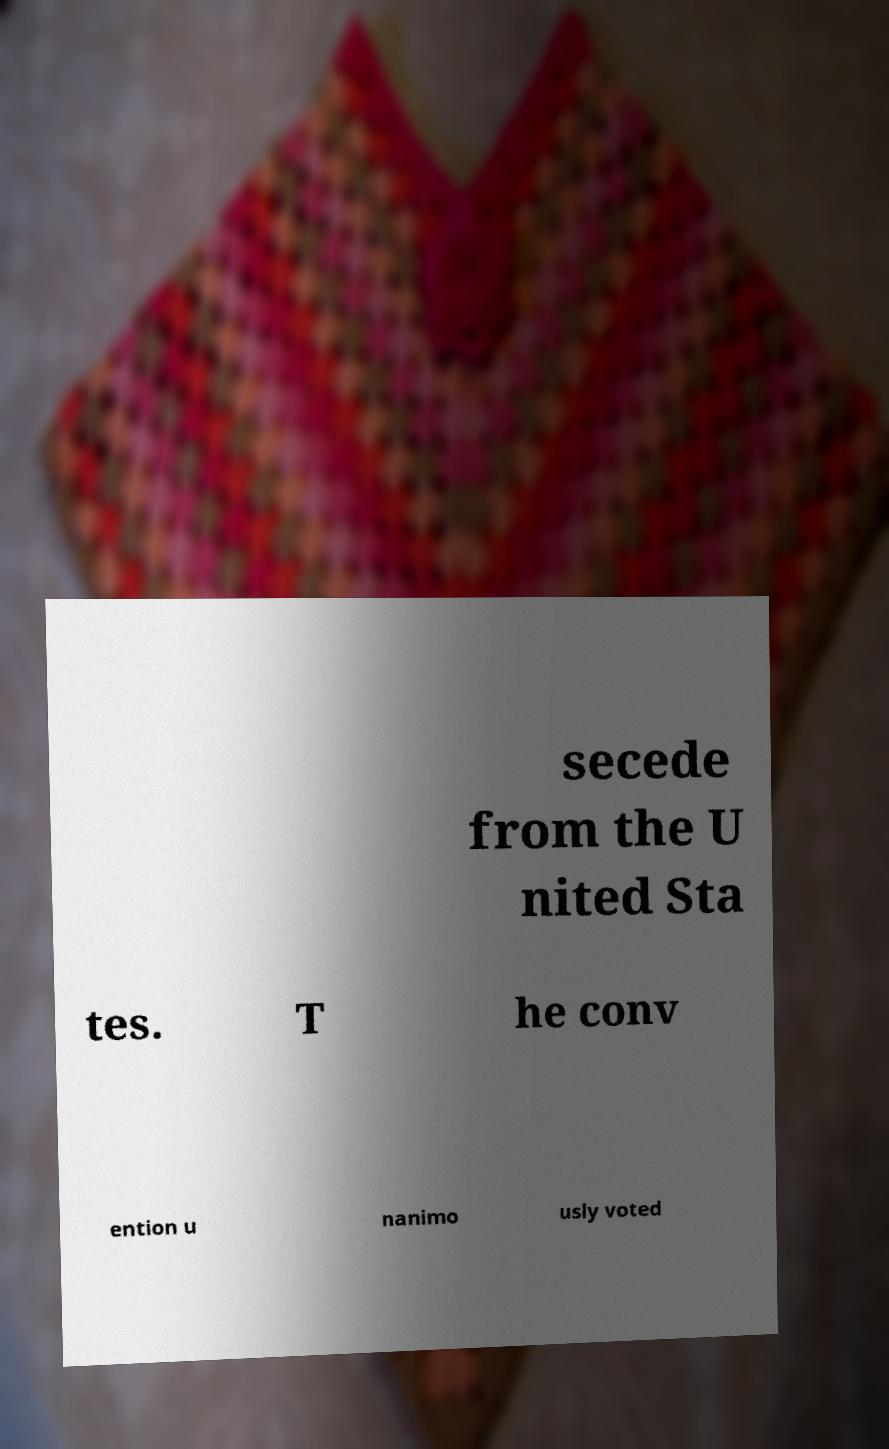Please read and relay the text visible in this image. What does it say? secede from the U nited Sta tes. T he conv ention u nanimo usly voted 